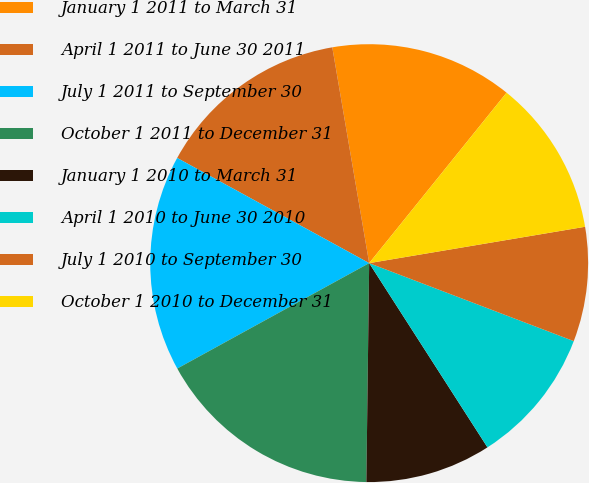<chart> <loc_0><loc_0><loc_500><loc_500><pie_chart><fcel>January 1 2011 to March 31<fcel>April 1 2011 to June 30 2011<fcel>July 1 2011 to September 30<fcel>October 1 2011 to December 31<fcel>January 1 2010 to March 31<fcel>April 1 2010 to June 30 2010<fcel>July 1 2010 to September 30<fcel>October 1 2010 to December 31<nl><fcel>13.49%<fcel>14.33%<fcel>15.97%<fcel>16.8%<fcel>9.29%<fcel>10.12%<fcel>8.45%<fcel>11.55%<nl></chart> 